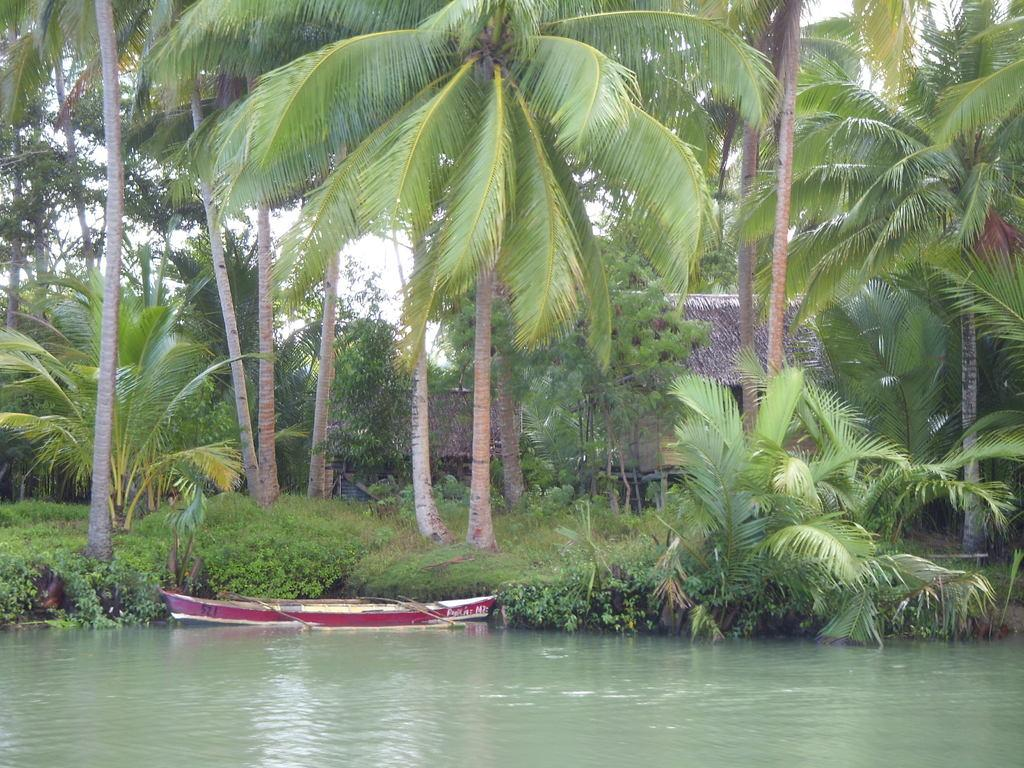What is the main feature of the image? The main feature of the image is water. What is floating on the water in the image? There is a boat in the image. What type of terrain can be seen in the image? The ground with grass is visible in the image. What type of vegetation is present in the image? There are plants and trees in the image. What type of structures are visible in the image? There are houses in the image. What part of the natural environment is visible in the image? The sky is visible in the image. What type of picture is the son holding in the image? There is no son or picture present in the image. 